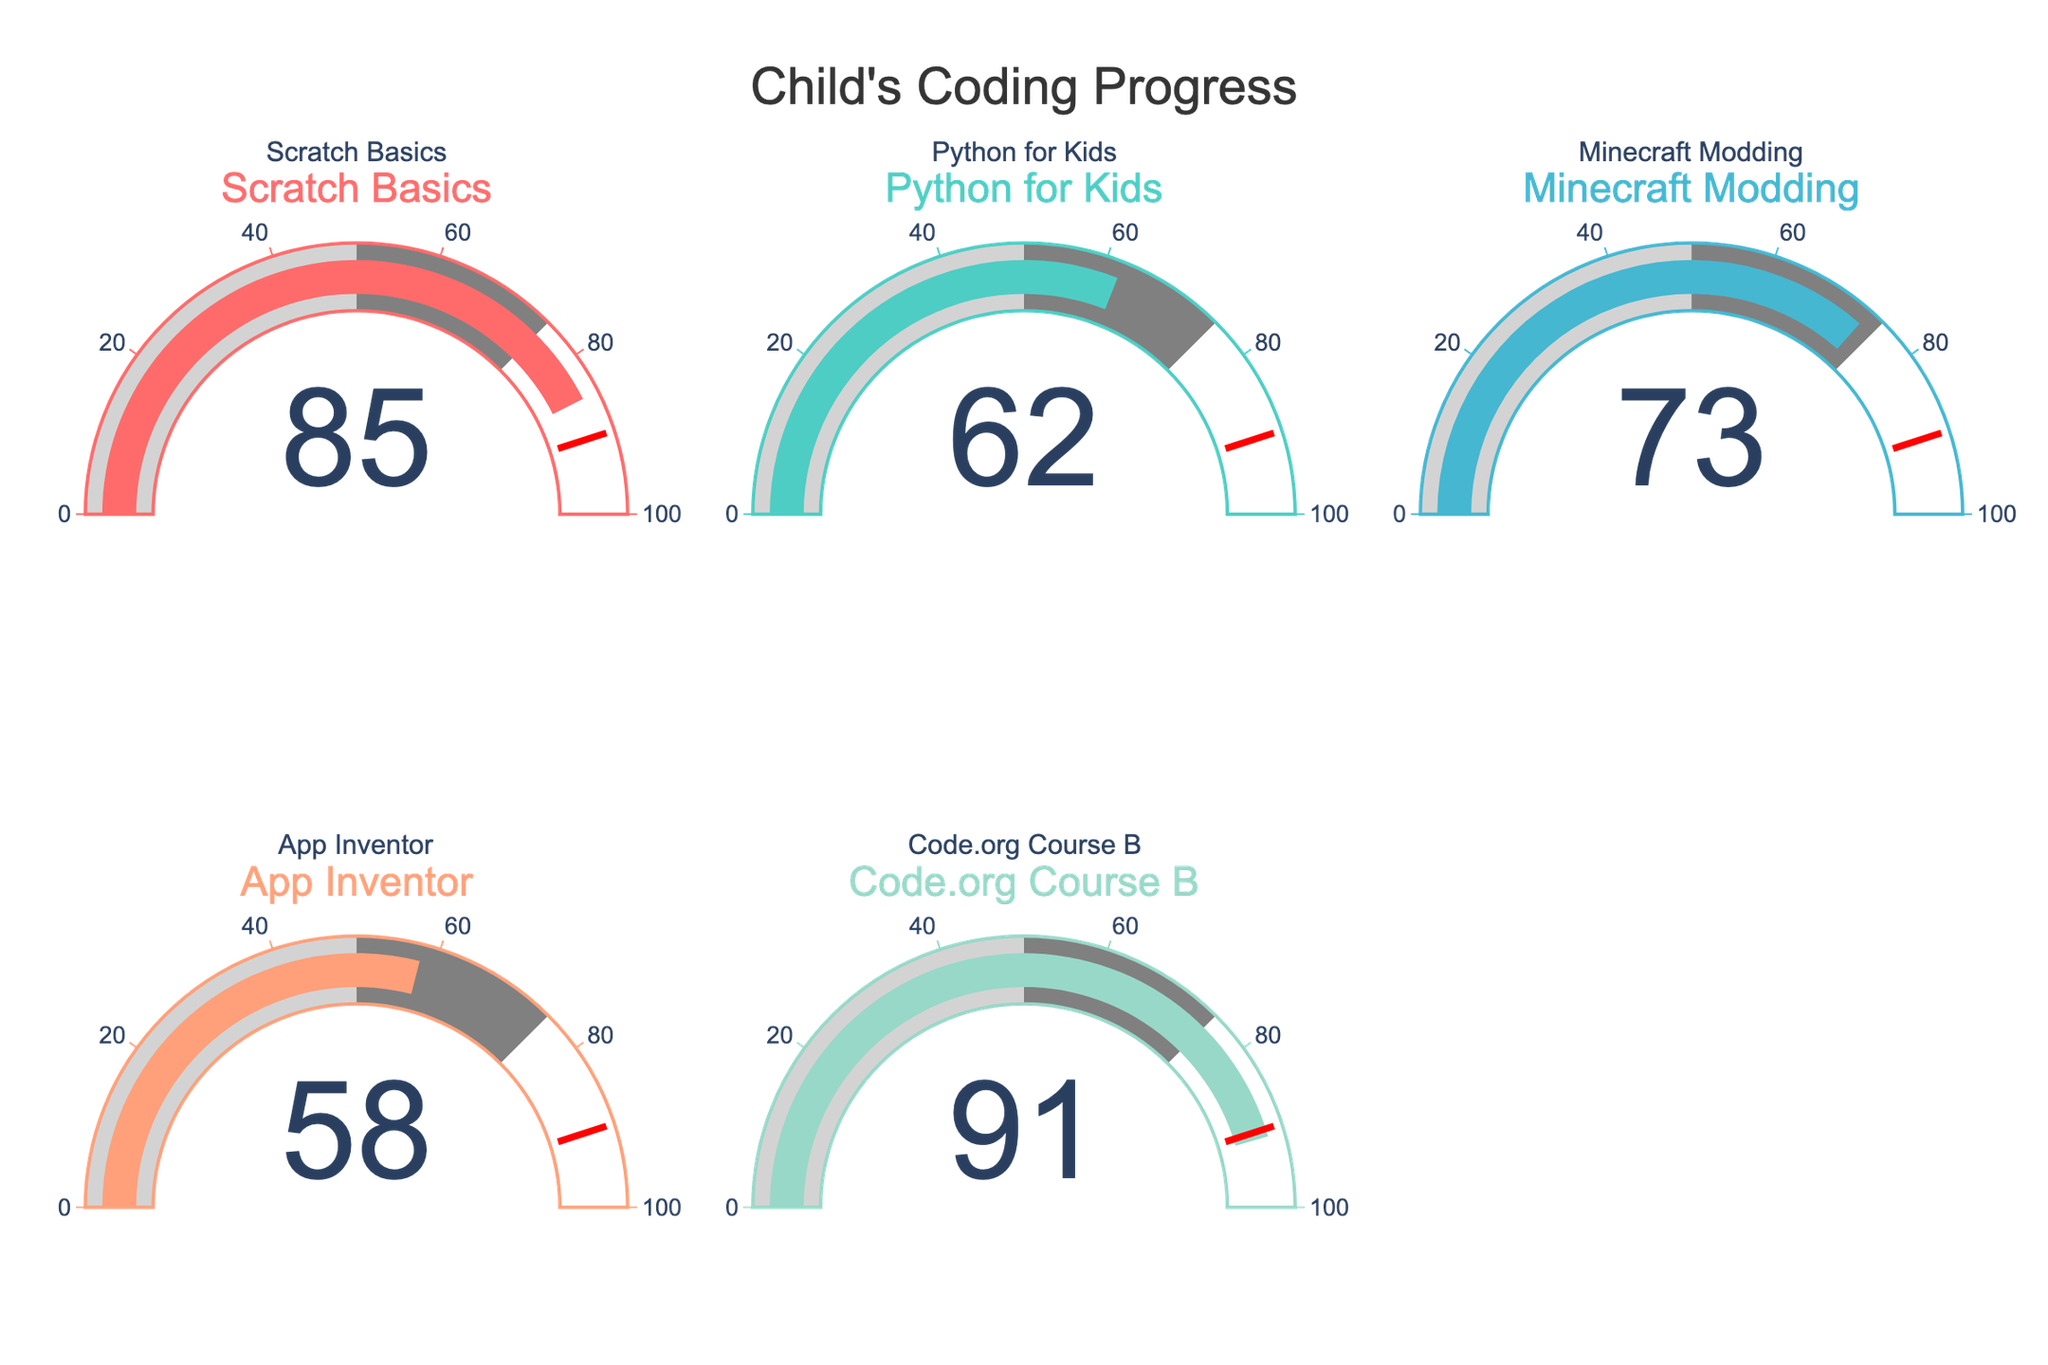What's the title of the figure? The title is centered at the top of the figure in large font and reads "Child's Coding Progress."
Answer: Child's Coding Progress How many gauge charts are there in the figure? There are five gauge charts arranged in two rows, with the second row having only two charts.
Answer: Five What is the percentage completion of the "Python for Kids" course? Locate the "Python for Kids" gauge, which displays the percentage of course completion in the center. It shows 62%.
Answer: 62% Which course has the highest completion percentage? Compare the values displayed in the center of each gauge. The "Code.org Course B" gauge shows the highest percentage at 91%.
Answer: Code.org Course B What is the average completion percentage across all courses? Add up the percentages: 85 (Scratch Basics) + 62 (Python for Kids) + 73 (Minecraft Modding) + 58 (App Inventor) + 91 (Code.org Course B) = 369. Divide by the number of courses, which is 5, to get the average: 369 / 5 = 73.8
Answer: 73.8 Which courses have a completion percentage below 60%? Identify the gauges with values below 60%. The gauges for "Python for Kids" (62%), and "App Inventor" (58%) fit this criterion.
Answer: App Inventor How many courses have a threshold mark at 90%? Check each gauge for the red threshold line marking 90%. All gauges have this mark.
Answer: All courses What is the difference in completion percentage between "Scratch Basics" and "App Inventor"? Subtract the completion percentage of "App Inventor" (58%) from that of "Scratch Basics" (85%): 85% - 58% = 27%.
Answer: 27 How are the colors of the gauge bars differentiated? Each gauge uses a distinct color to fill the bar, corresponding to unique shades of red, turquoise, blue, salmon, and mint.
Answer: Unique colors Which course has the closest completion percentage to the average completion percentage? Compute the difference between each course's completion and the average (73.8%). The "Minecraft Modding" course has a completion of 73%, which is closest to the average.
Answer: Minecraft Modding 